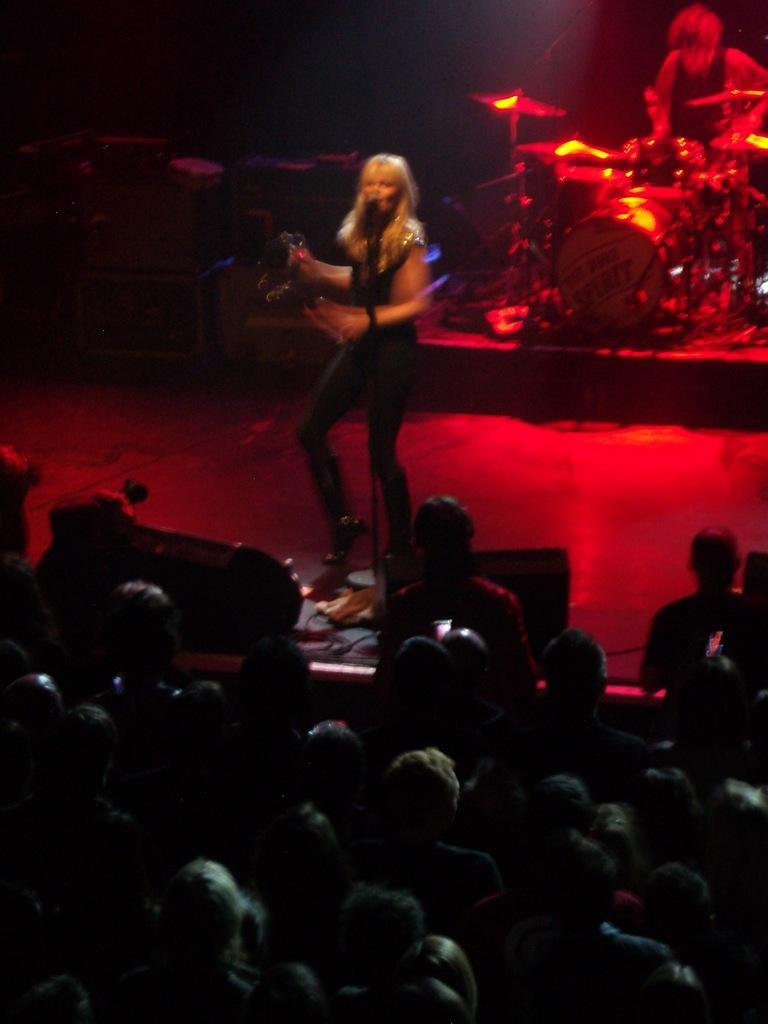What is happening in the image? There is an audience in the image, and a woman is singing while using a microphone. A man is also playing drums. Where are the woman and the man performing? Both the woman and the man are on a dais in the image. What instrument is the man playing? The man is playing drums in the image. What stage of development is the game in, as seen in the image? There is no game present in the image; it features a woman singing and a man playing drums. What is the top item visible in the image? There is no specific item mentioned as the "top" item in the image. The image primarily features a woman singing, a man playing drums, and an audience. 